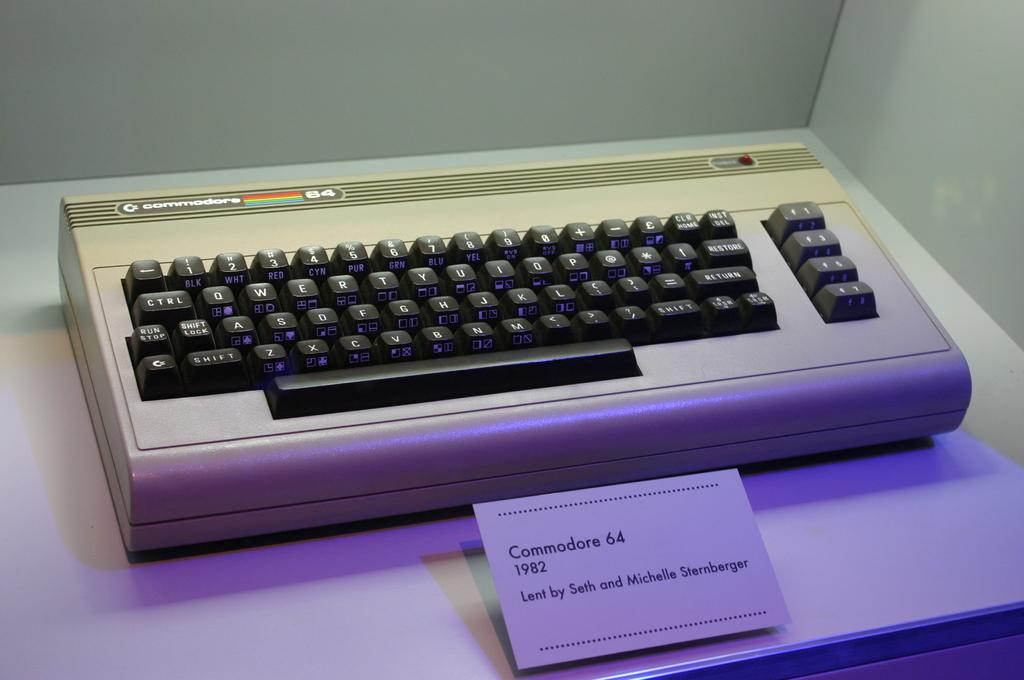<image>
Create a compact narrative representing the image presented. A display featuring a keyboard called the Commodore that was lent to the display by a couple named Seth and Michelle Sternberger. 